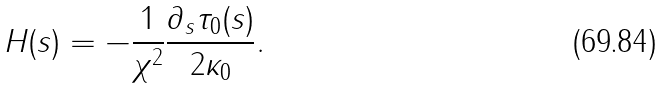<formula> <loc_0><loc_0><loc_500><loc_500>H ( s ) = - \frac { 1 } { \chi ^ { 2 } } \frac { \partial _ { s } \tau _ { 0 } ( s ) } { 2 \kappa _ { 0 } } .</formula> 